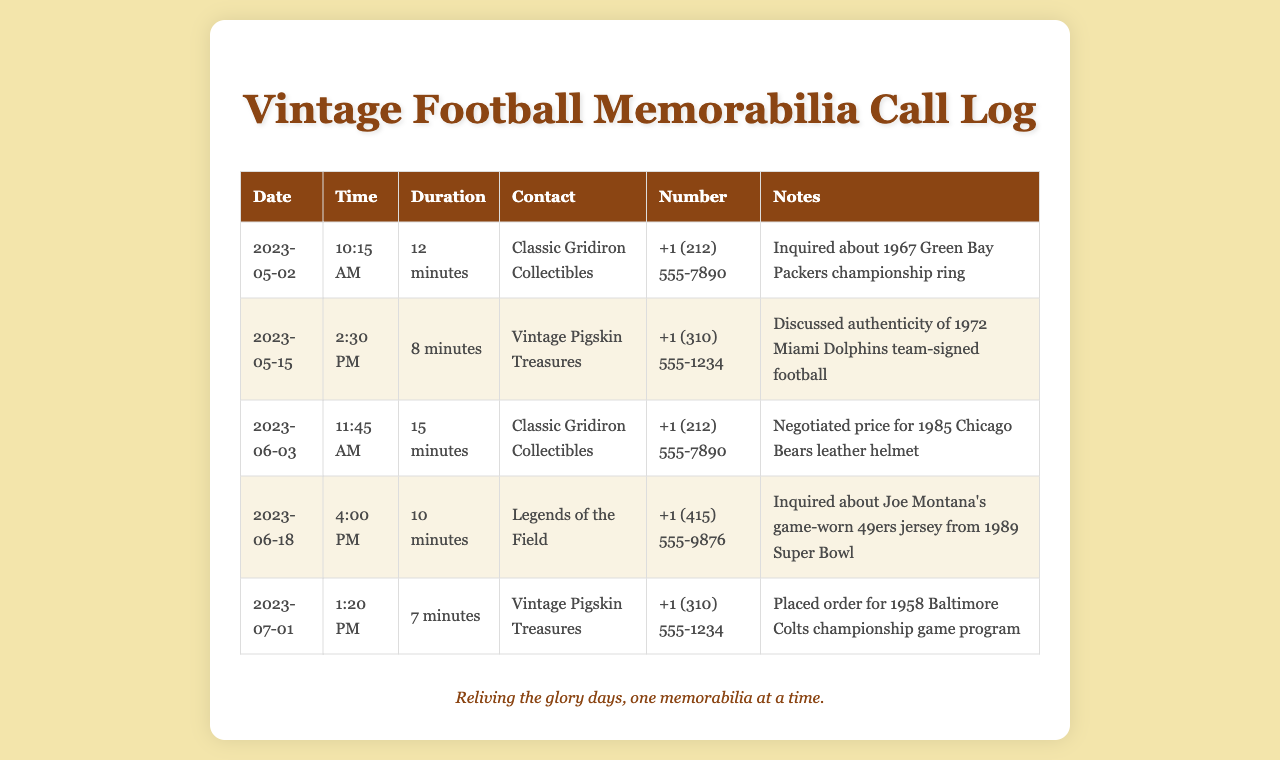What is the contact name for the call on May 2, 2023? The contact mentioned for that date is Classic Gridiron Collectibles.
Answer: Classic Gridiron Collectibles What was the duration of the call on June 18, 2023? The duration of the call for that date was recorded as 10 minutes.
Answer: 10 minutes What item did you inquire about during the call on May 15, 2023? During this call, the inquiry was about the authenticity of a specific football.
Answer: 1972 Miami Dolphins team-signed football How many calls were made to Vintage Pigskin Treasures? There are two calls logged to Vintage Pigskin Treasures in the document.
Answer: 2 What was the time of the call on July 1, 2023? The call on this date took place at 1:20 PM.
Answer: 1:20 PM Which dealer was contacted regarding Joe Montana's jersey? The dealer contacted for this item was Legends of the Field.
Answer: Legends of the Field When was the last recorded call in the log? The last recorded call in the log was on July 1, 2023.
Answer: July 1, 2023 What was the item ordered on July 1, 2023? The item placed on order during this call was a program.
Answer: 1958 Baltimore Colts championship game program 